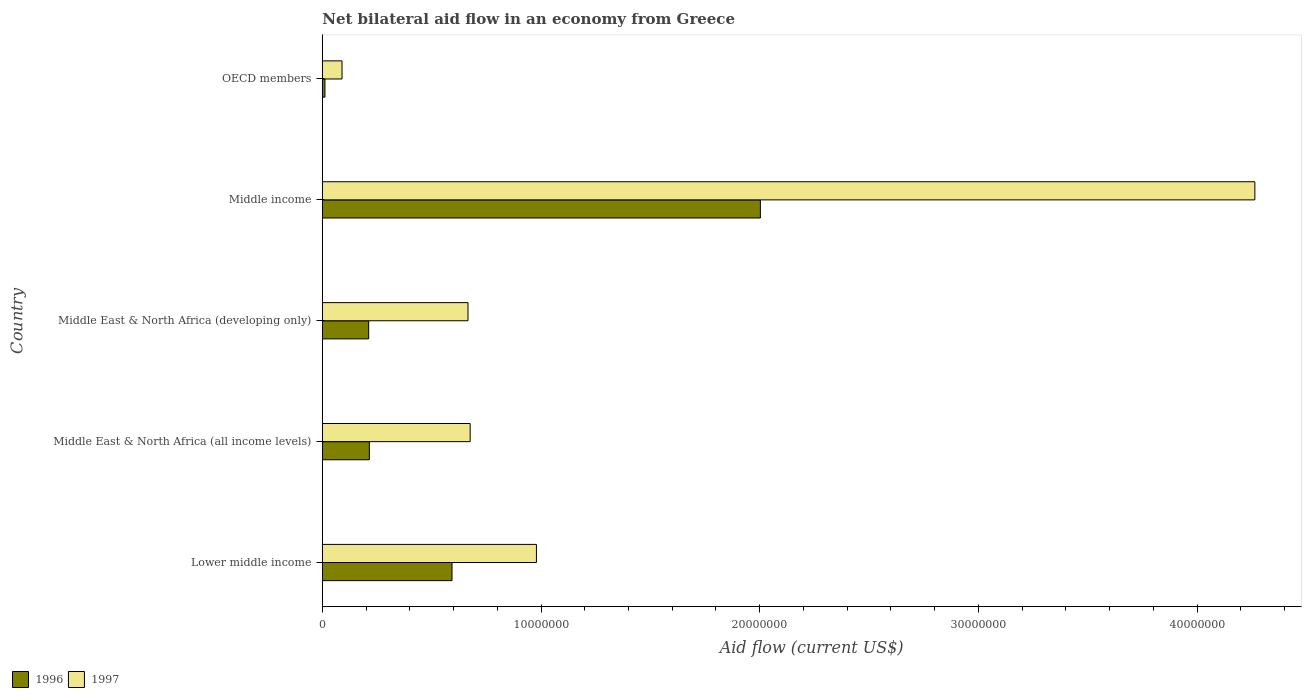How many different coloured bars are there?
Your answer should be very brief. 2. What is the label of the 3rd group of bars from the top?
Make the answer very short. Middle East & North Africa (developing only). Across all countries, what is the maximum net bilateral aid flow in 1997?
Offer a terse response. 4.26e+07. In which country was the net bilateral aid flow in 1996 maximum?
Make the answer very short. Middle income. What is the total net bilateral aid flow in 1997 in the graph?
Keep it short and to the point. 6.68e+07. What is the difference between the net bilateral aid flow in 1996 in Middle East & North Africa (all income levels) and that in Middle income?
Your answer should be very brief. -1.79e+07. What is the difference between the net bilateral aid flow in 1997 in OECD members and the net bilateral aid flow in 1996 in Middle East & North Africa (developing only)?
Your answer should be compact. -1.22e+06. What is the average net bilateral aid flow in 1997 per country?
Ensure brevity in your answer.  1.34e+07. What is the difference between the net bilateral aid flow in 1997 and net bilateral aid flow in 1996 in Middle income?
Give a very brief answer. 2.26e+07. In how many countries, is the net bilateral aid flow in 1996 greater than 16000000 US$?
Your answer should be very brief. 1. What is the ratio of the net bilateral aid flow in 1996 in Lower middle income to that in OECD members?
Your answer should be compact. 49.42. What is the difference between the highest and the second highest net bilateral aid flow in 1997?
Ensure brevity in your answer.  3.28e+07. What is the difference between the highest and the lowest net bilateral aid flow in 1997?
Offer a very short reply. 4.17e+07. In how many countries, is the net bilateral aid flow in 1996 greater than the average net bilateral aid flow in 1996 taken over all countries?
Your answer should be compact. 1. What does the 2nd bar from the bottom in OECD members represents?
Your answer should be compact. 1997. Does the graph contain any zero values?
Keep it short and to the point. No. Where does the legend appear in the graph?
Offer a terse response. Bottom left. How many legend labels are there?
Your answer should be compact. 2. How are the legend labels stacked?
Your answer should be compact. Horizontal. What is the title of the graph?
Provide a succinct answer. Net bilateral aid flow in an economy from Greece. Does "1968" appear as one of the legend labels in the graph?
Give a very brief answer. No. What is the label or title of the X-axis?
Keep it short and to the point. Aid flow (current US$). What is the label or title of the Y-axis?
Give a very brief answer. Country. What is the Aid flow (current US$) of 1996 in Lower middle income?
Offer a very short reply. 5.93e+06. What is the Aid flow (current US$) of 1997 in Lower middle income?
Your answer should be compact. 9.79e+06. What is the Aid flow (current US$) in 1996 in Middle East & North Africa (all income levels)?
Provide a succinct answer. 2.15e+06. What is the Aid flow (current US$) of 1997 in Middle East & North Africa (all income levels)?
Make the answer very short. 6.76e+06. What is the Aid flow (current US$) in 1996 in Middle East & North Africa (developing only)?
Provide a short and direct response. 2.12e+06. What is the Aid flow (current US$) of 1997 in Middle East & North Africa (developing only)?
Ensure brevity in your answer.  6.66e+06. What is the Aid flow (current US$) of 1996 in Middle income?
Give a very brief answer. 2.00e+07. What is the Aid flow (current US$) in 1997 in Middle income?
Your answer should be compact. 4.26e+07. What is the Aid flow (current US$) in 1996 in OECD members?
Provide a succinct answer. 1.20e+05. Across all countries, what is the maximum Aid flow (current US$) in 1996?
Keep it short and to the point. 2.00e+07. Across all countries, what is the maximum Aid flow (current US$) of 1997?
Offer a terse response. 4.26e+07. Across all countries, what is the minimum Aid flow (current US$) of 1997?
Your response must be concise. 9.00e+05. What is the total Aid flow (current US$) in 1996 in the graph?
Offer a very short reply. 3.04e+07. What is the total Aid flow (current US$) of 1997 in the graph?
Offer a terse response. 6.68e+07. What is the difference between the Aid flow (current US$) of 1996 in Lower middle income and that in Middle East & North Africa (all income levels)?
Offer a very short reply. 3.78e+06. What is the difference between the Aid flow (current US$) in 1997 in Lower middle income and that in Middle East & North Africa (all income levels)?
Make the answer very short. 3.03e+06. What is the difference between the Aid flow (current US$) in 1996 in Lower middle income and that in Middle East & North Africa (developing only)?
Your answer should be very brief. 3.81e+06. What is the difference between the Aid flow (current US$) in 1997 in Lower middle income and that in Middle East & North Africa (developing only)?
Your answer should be very brief. 3.13e+06. What is the difference between the Aid flow (current US$) of 1996 in Lower middle income and that in Middle income?
Keep it short and to the point. -1.41e+07. What is the difference between the Aid flow (current US$) of 1997 in Lower middle income and that in Middle income?
Your answer should be very brief. -3.28e+07. What is the difference between the Aid flow (current US$) in 1996 in Lower middle income and that in OECD members?
Provide a short and direct response. 5.81e+06. What is the difference between the Aid flow (current US$) of 1997 in Lower middle income and that in OECD members?
Keep it short and to the point. 8.89e+06. What is the difference between the Aid flow (current US$) of 1997 in Middle East & North Africa (all income levels) and that in Middle East & North Africa (developing only)?
Keep it short and to the point. 1.00e+05. What is the difference between the Aid flow (current US$) in 1996 in Middle East & North Africa (all income levels) and that in Middle income?
Keep it short and to the point. -1.79e+07. What is the difference between the Aid flow (current US$) of 1997 in Middle East & North Africa (all income levels) and that in Middle income?
Provide a short and direct response. -3.59e+07. What is the difference between the Aid flow (current US$) of 1996 in Middle East & North Africa (all income levels) and that in OECD members?
Offer a very short reply. 2.03e+06. What is the difference between the Aid flow (current US$) of 1997 in Middle East & North Africa (all income levels) and that in OECD members?
Ensure brevity in your answer.  5.86e+06. What is the difference between the Aid flow (current US$) in 1996 in Middle East & North Africa (developing only) and that in Middle income?
Provide a succinct answer. -1.79e+07. What is the difference between the Aid flow (current US$) of 1997 in Middle East & North Africa (developing only) and that in Middle income?
Give a very brief answer. -3.60e+07. What is the difference between the Aid flow (current US$) of 1996 in Middle East & North Africa (developing only) and that in OECD members?
Keep it short and to the point. 2.00e+06. What is the difference between the Aid flow (current US$) of 1997 in Middle East & North Africa (developing only) and that in OECD members?
Your answer should be very brief. 5.76e+06. What is the difference between the Aid flow (current US$) in 1996 in Middle income and that in OECD members?
Your answer should be very brief. 1.99e+07. What is the difference between the Aid flow (current US$) in 1997 in Middle income and that in OECD members?
Provide a short and direct response. 4.17e+07. What is the difference between the Aid flow (current US$) in 1996 in Lower middle income and the Aid flow (current US$) in 1997 in Middle East & North Africa (all income levels)?
Your answer should be very brief. -8.30e+05. What is the difference between the Aid flow (current US$) in 1996 in Lower middle income and the Aid flow (current US$) in 1997 in Middle East & North Africa (developing only)?
Offer a very short reply. -7.30e+05. What is the difference between the Aid flow (current US$) in 1996 in Lower middle income and the Aid flow (current US$) in 1997 in Middle income?
Keep it short and to the point. -3.67e+07. What is the difference between the Aid flow (current US$) in 1996 in Lower middle income and the Aid flow (current US$) in 1997 in OECD members?
Your answer should be compact. 5.03e+06. What is the difference between the Aid flow (current US$) in 1996 in Middle East & North Africa (all income levels) and the Aid flow (current US$) in 1997 in Middle East & North Africa (developing only)?
Provide a short and direct response. -4.51e+06. What is the difference between the Aid flow (current US$) of 1996 in Middle East & North Africa (all income levels) and the Aid flow (current US$) of 1997 in Middle income?
Provide a succinct answer. -4.05e+07. What is the difference between the Aid flow (current US$) of 1996 in Middle East & North Africa (all income levels) and the Aid flow (current US$) of 1997 in OECD members?
Offer a terse response. 1.25e+06. What is the difference between the Aid flow (current US$) of 1996 in Middle East & North Africa (developing only) and the Aid flow (current US$) of 1997 in Middle income?
Provide a succinct answer. -4.05e+07. What is the difference between the Aid flow (current US$) of 1996 in Middle East & North Africa (developing only) and the Aid flow (current US$) of 1997 in OECD members?
Ensure brevity in your answer.  1.22e+06. What is the difference between the Aid flow (current US$) of 1996 in Middle income and the Aid flow (current US$) of 1997 in OECD members?
Your response must be concise. 1.91e+07. What is the average Aid flow (current US$) of 1996 per country?
Give a very brief answer. 6.07e+06. What is the average Aid flow (current US$) in 1997 per country?
Keep it short and to the point. 1.34e+07. What is the difference between the Aid flow (current US$) in 1996 and Aid flow (current US$) in 1997 in Lower middle income?
Your answer should be very brief. -3.86e+06. What is the difference between the Aid flow (current US$) of 1996 and Aid flow (current US$) of 1997 in Middle East & North Africa (all income levels)?
Your answer should be very brief. -4.61e+06. What is the difference between the Aid flow (current US$) of 1996 and Aid flow (current US$) of 1997 in Middle East & North Africa (developing only)?
Your answer should be very brief. -4.54e+06. What is the difference between the Aid flow (current US$) of 1996 and Aid flow (current US$) of 1997 in Middle income?
Your answer should be compact. -2.26e+07. What is the difference between the Aid flow (current US$) of 1996 and Aid flow (current US$) of 1997 in OECD members?
Your answer should be very brief. -7.80e+05. What is the ratio of the Aid flow (current US$) in 1996 in Lower middle income to that in Middle East & North Africa (all income levels)?
Provide a short and direct response. 2.76. What is the ratio of the Aid flow (current US$) in 1997 in Lower middle income to that in Middle East & North Africa (all income levels)?
Give a very brief answer. 1.45. What is the ratio of the Aid flow (current US$) of 1996 in Lower middle income to that in Middle East & North Africa (developing only)?
Offer a very short reply. 2.8. What is the ratio of the Aid flow (current US$) in 1997 in Lower middle income to that in Middle East & North Africa (developing only)?
Your answer should be compact. 1.47. What is the ratio of the Aid flow (current US$) in 1996 in Lower middle income to that in Middle income?
Offer a very short reply. 0.3. What is the ratio of the Aid flow (current US$) in 1997 in Lower middle income to that in Middle income?
Give a very brief answer. 0.23. What is the ratio of the Aid flow (current US$) of 1996 in Lower middle income to that in OECD members?
Provide a succinct answer. 49.42. What is the ratio of the Aid flow (current US$) of 1997 in Lower middle income to that in OECD members?
Provide a succinct answer. 10.88. What is the ratio of the Aid flow (current US$) of 1996 in Middle East & North Africa (all income levels) to that in Middle East & North Africa (developing only)?
Provide a succinct answer. 1.01. What is the ratio of the Aid flow (current US$) in 1996 in Middle East & North Africa (all income levels) to that in Middle income?
Provide a short and direct response. 0.11. What is the ratio of the Aid flow (current US$) in 1997 in Middle East & North Africa (all income levels) to that in Middle income?
Ensure brevity in your answer.  0.16. What is the ratio of the Aid flow (current US$) of 1996 in Middle East & North Africa (all income levels) to that in OECD members?
Ensure brevity in your answer.  17.92. What is the ratio of the Aid flow (current US$) in 1997 in Middle East & North Africa (all income levels) to that in OECD members?
Provide a short and direct response. 7.51. What is the ratio of the Aid flow (current US$) of 1996 in Middle East & North Africa (developing only) to that in Middle income?
Ensure brevity in your answer.  0.11. What is the ratio of the Aid flow (current US$) in 1997 in Middle East & North Africa (developing only) to that in Middle income?
Offer a very short reply. 0.16. What is the ratio of the Aid flow (current US$) of 1996 in Middle East & North Africa (developing only) to that in OECD members?
Offer a very short reply. 17.67. What is the ratio of the Aid flow (current US$) of 1997 in Middle East & North Africa (developing only) to that in OECD members?
Your answer should be very brief. 7.4. What is the ratio of the Aid flow (current US$) in 1996 in Middle income to that in OECD members?
Provide a succinct answer. 166.92. What is the ratio of the Aid flow (current US$) in 1997 in Middle income to that in OECD members?
Offer a very short reply. 47.38. What is the difference between the highest and the second highest Aid flow (current US$) of 1996?
Make the answer very short. 1.41e+07. What is the difference between the highest and the second highest Aid flow (current US$) of 1997?
Your response must be concise. 3.28e+07. What is the difference between the highest and the lowest Aid flow (current US$) in 1996?
Provide a succinct answer. 1.99e+07. What is the difference between the highest and the lowest Aid flow (current US$) of 1997?
Make the answer very short. 4.17e+07. 